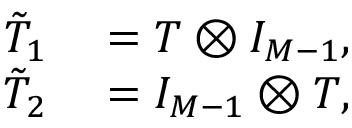<formula> <loc_0><loc_0><loc_500><loc_500>\begin{array} { r l } { \tilde { T } _ { 1 } } & = T \otimes I _ { M - 1 } , } \\ { \tilde { T } _ { 2 } } & = I _ { M - 1 } \otimes T , } \end{array}</formula> 